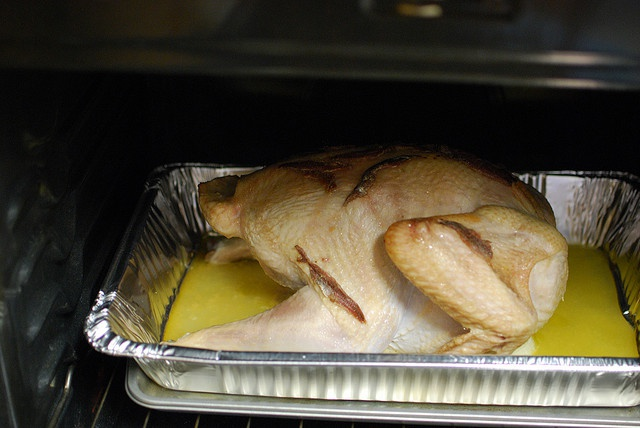Describe the objects in this image and their specific colors. I can see oven in black, tan, olive, and darkgray tones and bird in black, tan, and olive tones in this image. 